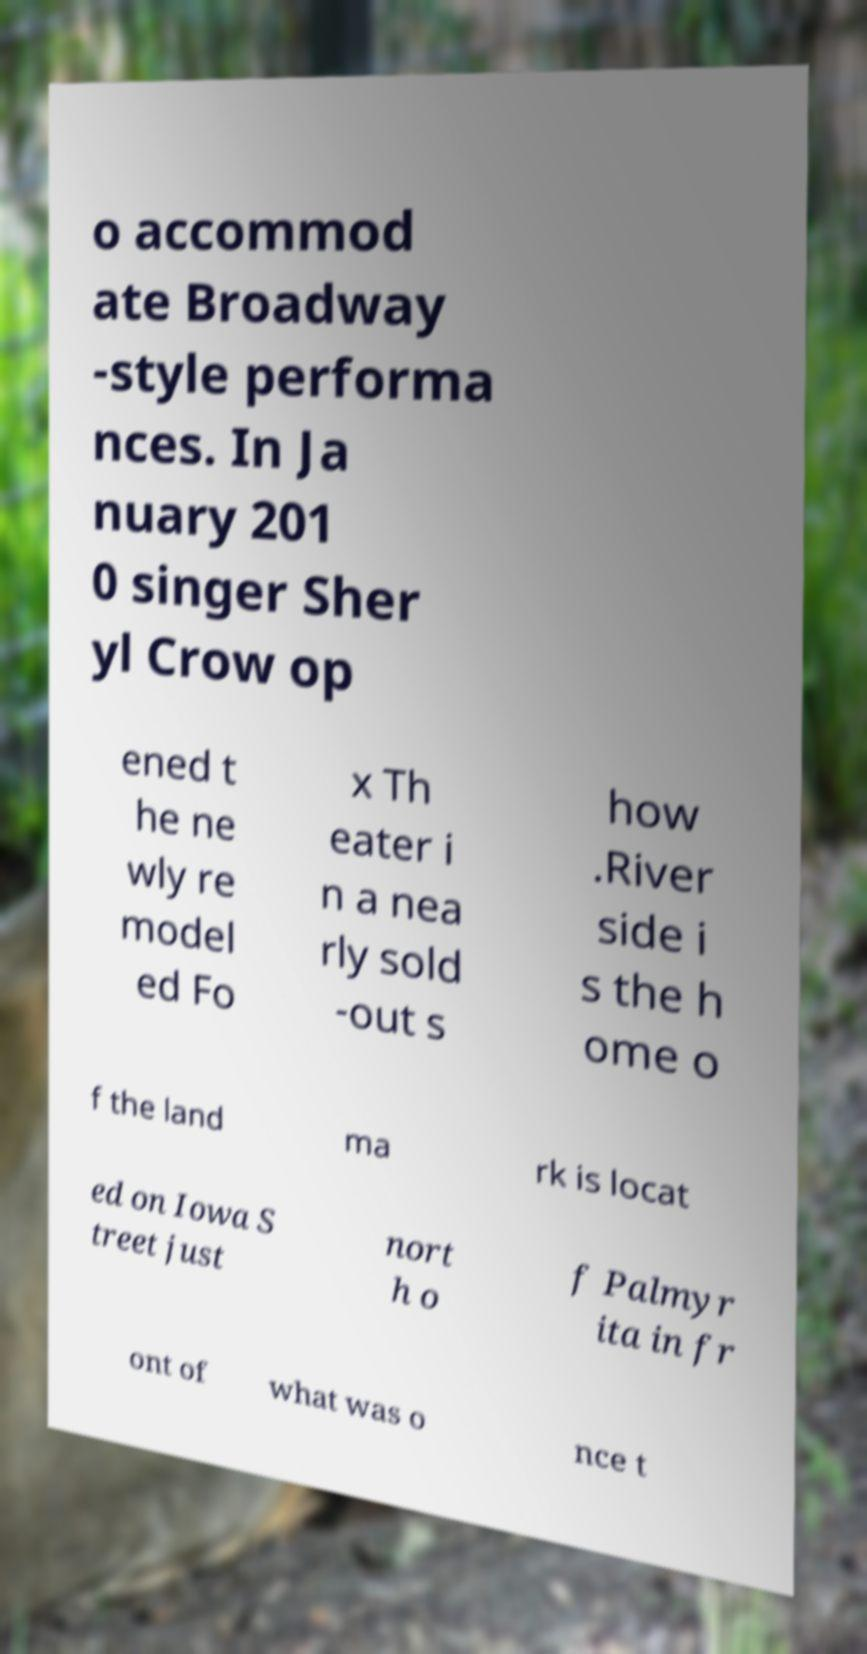Can you read and provide the text displayed in the image?This photo seems to have some interesting text. Can you extract and type it out for me? o accommod ate Broadway -style performa nces. In Ja nuary 201 0 singer Sher yl Crow op ened t he ne wly re model ed Fo x Th eater i n a nea rly sold -out s how .River side i s the h ome o f the land ma rk is locat ed on Iowa S treet just nort h o f Palmyr ita in fr ont of what was o nce t 